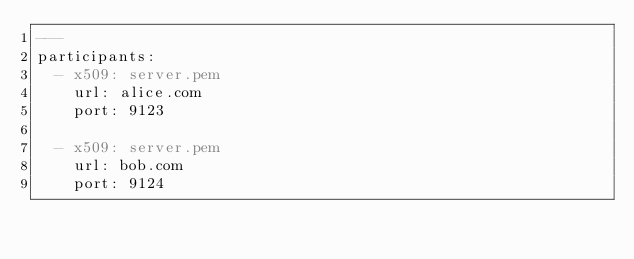Convert code to text. <code><loc_0><loc_0><loc_500><loc_500><_YAML_>---
participants:
  - x509: server.pem
    url: alice.com
    port: 9123

  - x509: server.pem
    url: bob.com
    port: 9124</code> 